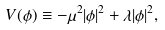<formula> <loc_0><loc_0><loc_500><loc_500>V ( \phi ) \equiv - \mu ^ { 2 } | \phi | ^ { 2 } + \lambda | \phi | ^ { 2 } ,</formula> 